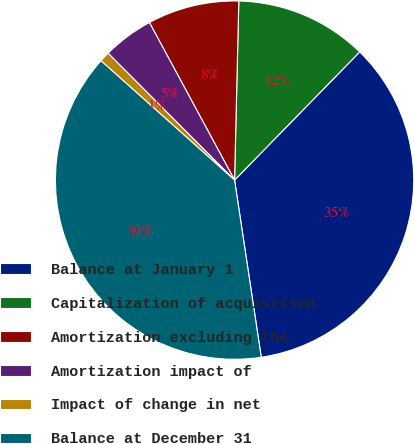<chart> <loc_0><loc_0><loc_500><loc_500><pie_chart><fcel>Balance at January 1<fcel>Capitalization of acquisition<fcel>Amortization excluding the<fcel>Amortization impact of<fcel>Impact of change in net<fcel>Balance at December 31<nl><fcel>35.31%<fcel>11.93%<fcel>8.26%<fcel>4.59%<fcel>0.92%<fcel>38.98%<nl></chart> 